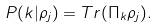<formula> <loc_0><loc_0><loc_500><loc_500>P ( k | { \rho } _ { j } ) = T r ( { \Pi } _ { k } { \rho } _ { j } ) .</formula> 